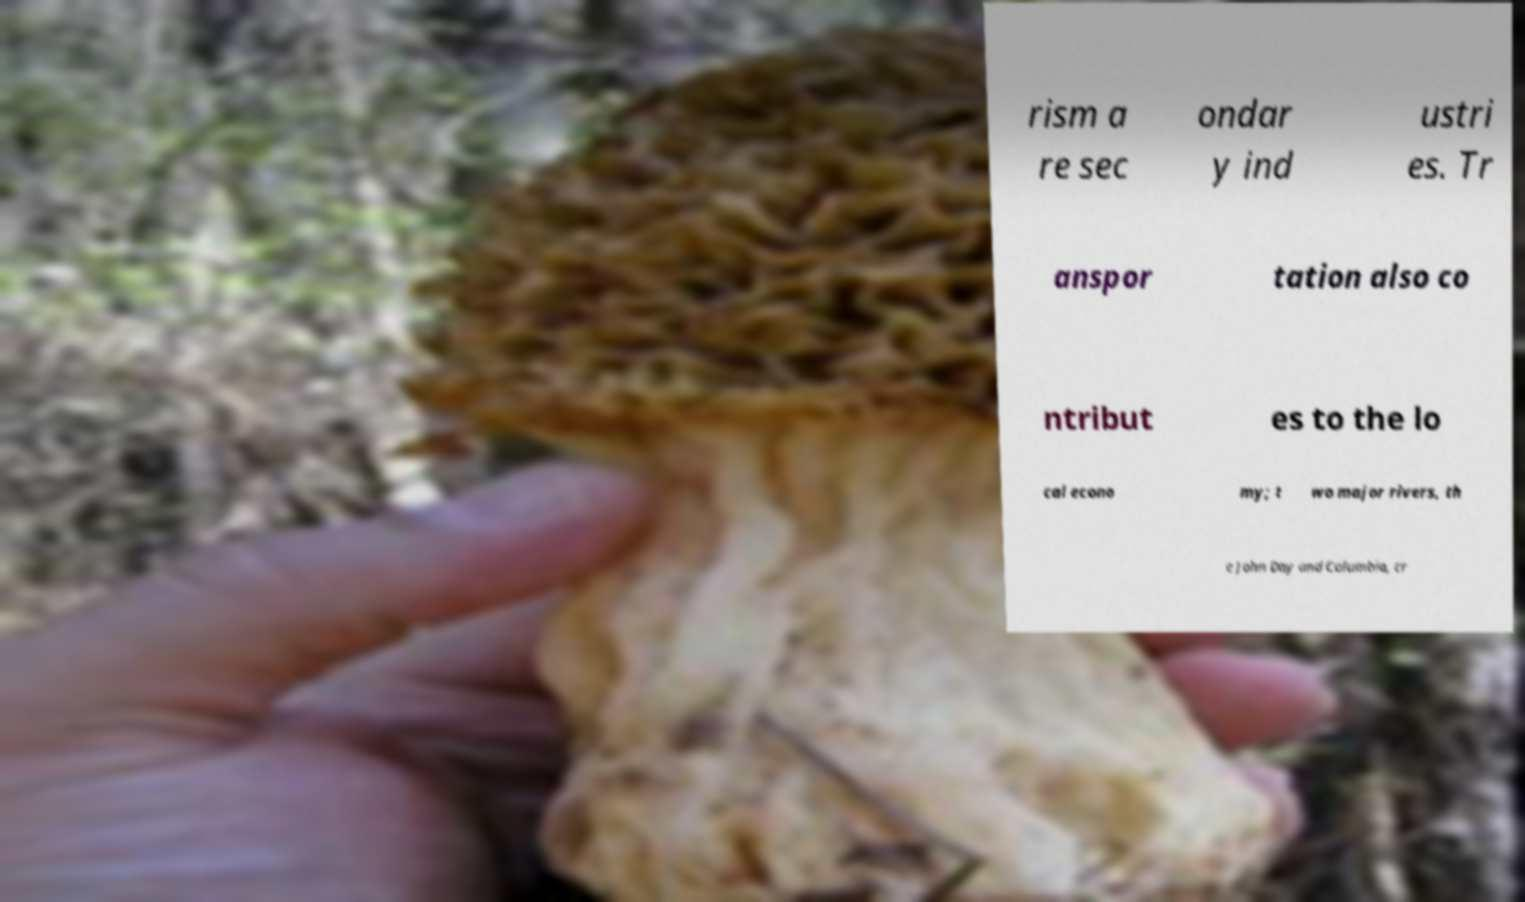There's text embedded in this image that I need extracted. Can you transcribe it verbatim? rism a re sec ondar y ind ustri es. Tr anspor tation also co ntribut es to the lo cal econo my; t wo major rivers, th e John Day and Columbia, cr 